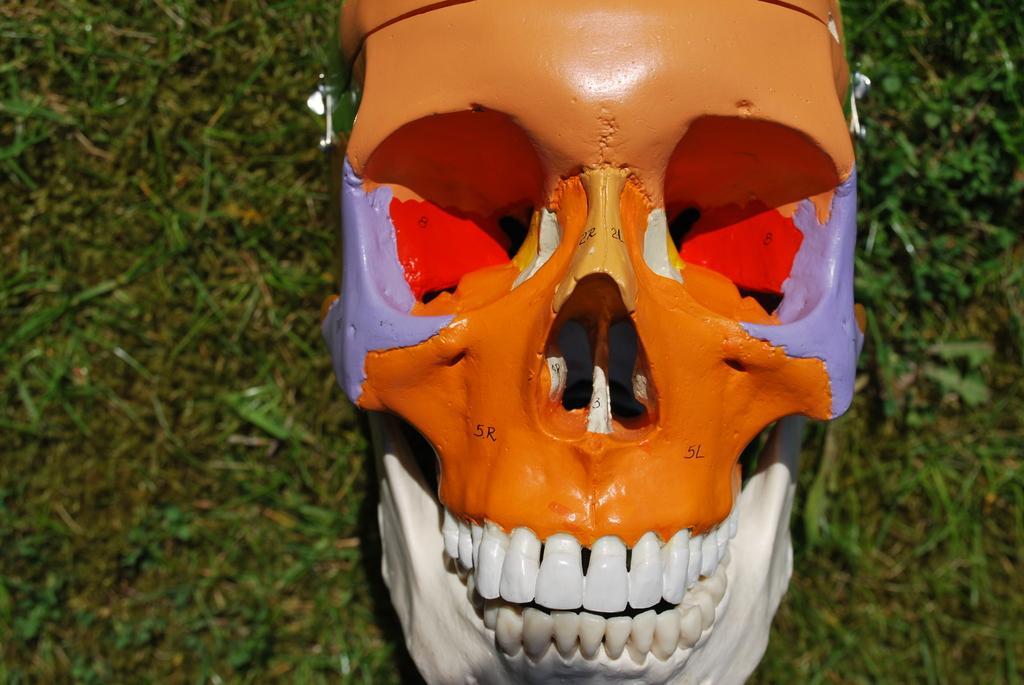Please provide a concise description of this image. In this image on the ground there is a skull. The skull is painted with different colors. 